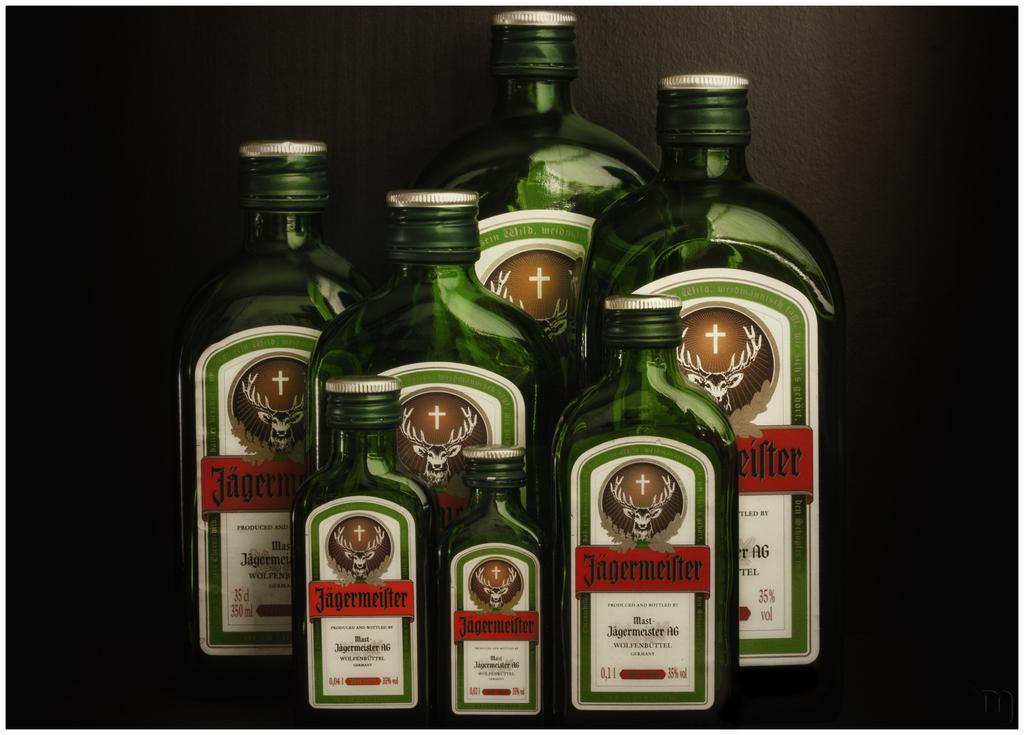<image>
Write a terse but informative summary of the picture. a set of various sizes of Jagermeifter liquor bottles displayed. 